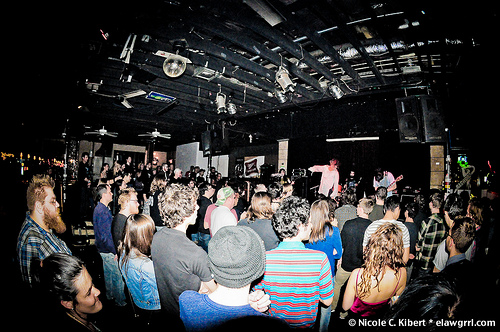<image>
Can you confirm if the hat is on the person? No. The hat is not positioned on the person. They may be near each other, but the hat is not supported by or resting on top of the person. Is there a boy in front of the girl? No. The boy is not in front of the girl. The spatial positioning shows a different relationship between these objects. 